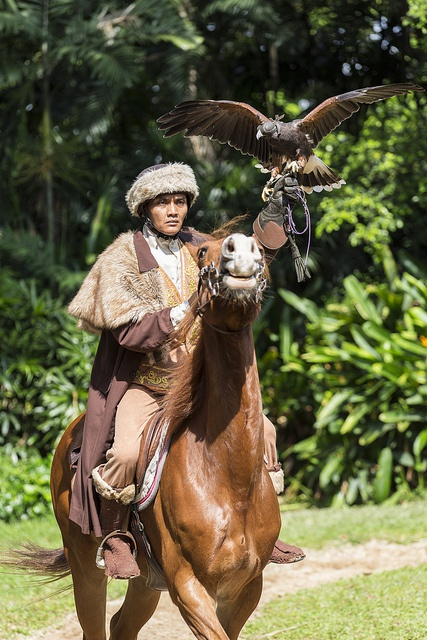Describe the objects in this image and their specific colors. I can see horse in darkgreen, black, maroon, and brown tones, people in darkgreen, black, lightgray, gray, and tan tones, and bird in darkgreen, black, and gray tones in this image. 